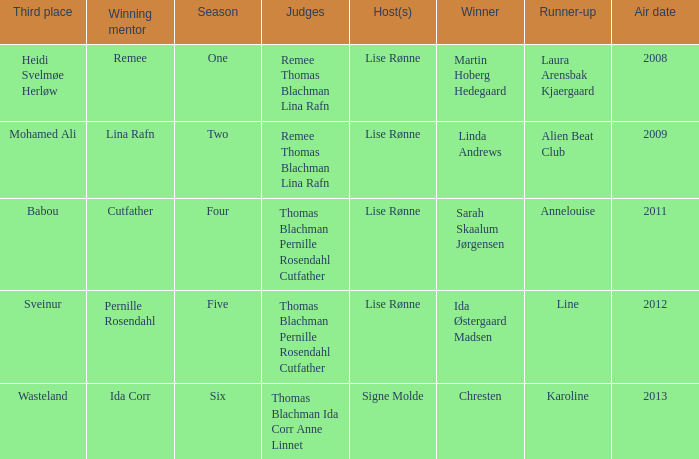Can you parse all the data within this table? {'header': ['Third place', 'Winning mentor', 'Season', 'Judges', 'Host(s)', 'Winner', 'Runner-up', 'Air date'], 'rows': [['Heidi Svelmøe Herløw', 'Remee', 'One', 'Remee Thomas Blachman Lina Rafn', 'Lise Rønne', 'Martin Hoberg Hedegaard', 'Laura Arensbak Kjaergaard', '2008'], ['Mohamed Ali', 'Lina Rafn', 'Two', 'Remee Thomas Blachman Lina Rafn', 'Lise Rønne', 'Linda Andrews', 'Alien Beat Club', '2009'], ['Babou', 'Cutfather', 'Four', 'Thomas Blachman Pernille Rosendahl Cutfather', 'Lise Rønne', 'Sarah Skaalum Jørgensen', 'Annelouise', '2011'], ['Sveinur', 'Pernille Rosendahl', 'Five', 'Thomas Blachman Pernille Rosendahl Cutfather', 'Lise Rønne', 'Ida Østergaard Madsen', 'Line', '2012'], ['Wasteland', 'Ida Corr', 'Six', 'Thomas Blachman Ida Corr Anne Linnet', 'Signe Molde', 'Chresten', 'Karoline', '2013']]} Who was the winning mentor in season two? Lina Rafn. 